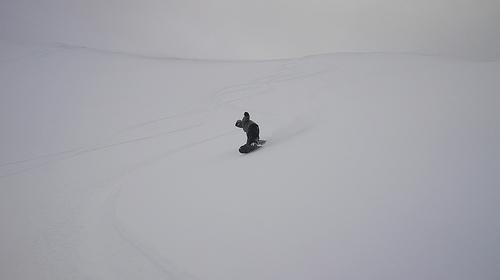Identify the primary action taking place in the image. A man is snowboarding down a snowy mountain slope. Mention the appearance of the snowboard being used by the man. The snowboard is black and has a width of 26 units and a height of 26 units. What is the dominant color scheme of the photograph itself? The photograph is black and white with snow covering the ground. State one distinctive feature of the mountain's horizon. There is a dip on the horizon of the mountain. What kind of trails can be seen on the snowy ground? There are ski trails in powdery snow and lines in the snow from previous snowboarding. Describe the interaction between the man and his snowboard. The man is leaning over, trying to keep his balance while snowboarding, with his left arm and hand outstretched in the air. Count and describe the various patches of white snow in the image. There are 10 patches of white snow with varying sizes and positions. Provide a brief description of the weather and environment in the image. It is a grey, overcast day in a snow-covered mountainous area. Enumerate the visible clothing items the man is wearing. The man is wearing a cream-colored jacket with a hood, black snow pants, and full snow gear. 